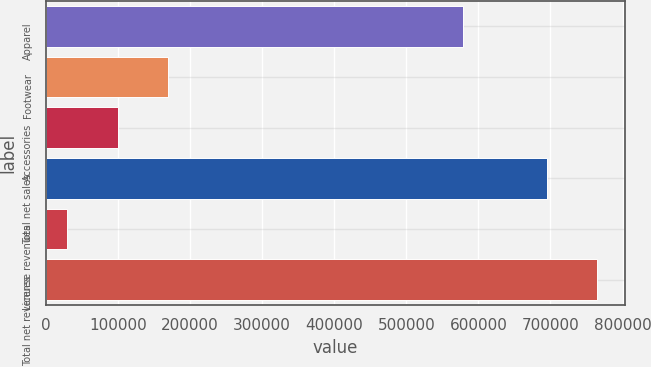Convert chart. <chart><loc_0><loc_0><loc_500><loc_500><bar_chart><fcel>Apparel<fcel>Footwear<fcel>Accessories<fcel>Total net sales<fcel>License revenues<fcel>Total net revenues<nl><fcel>578887<fcel>169018<fcel>99490.2<fcel>695282<fcel>29962<fcel>764810<nl></chart> 